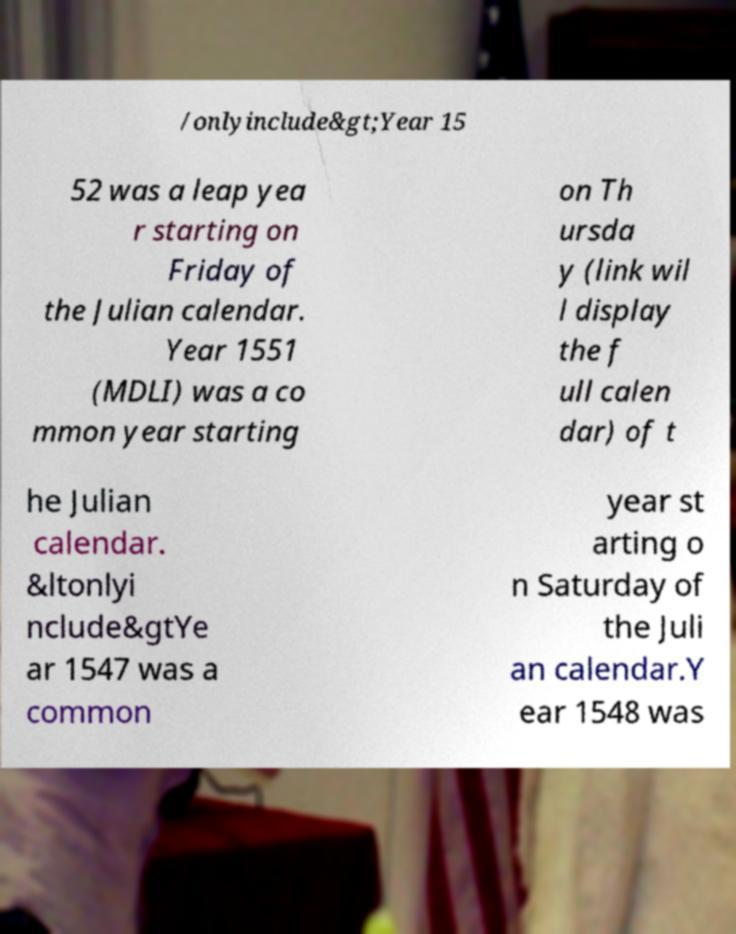Could you assist in decoding the text presented in this image and type it out clearly? /onlyinclude&gt;Year 15 52 was a leap yea r starting on Friday of the Julian calendar. Year 1551 (MDLI) was a co mmon year starting on Th ursda y (link wil l display the f ull calen dar) of t he Julian calendar. &ltonlyi nclude&gtYe ar 1547 was a common year st arting o n Saturday of the Juli an calendar.Y ear 1548 was 